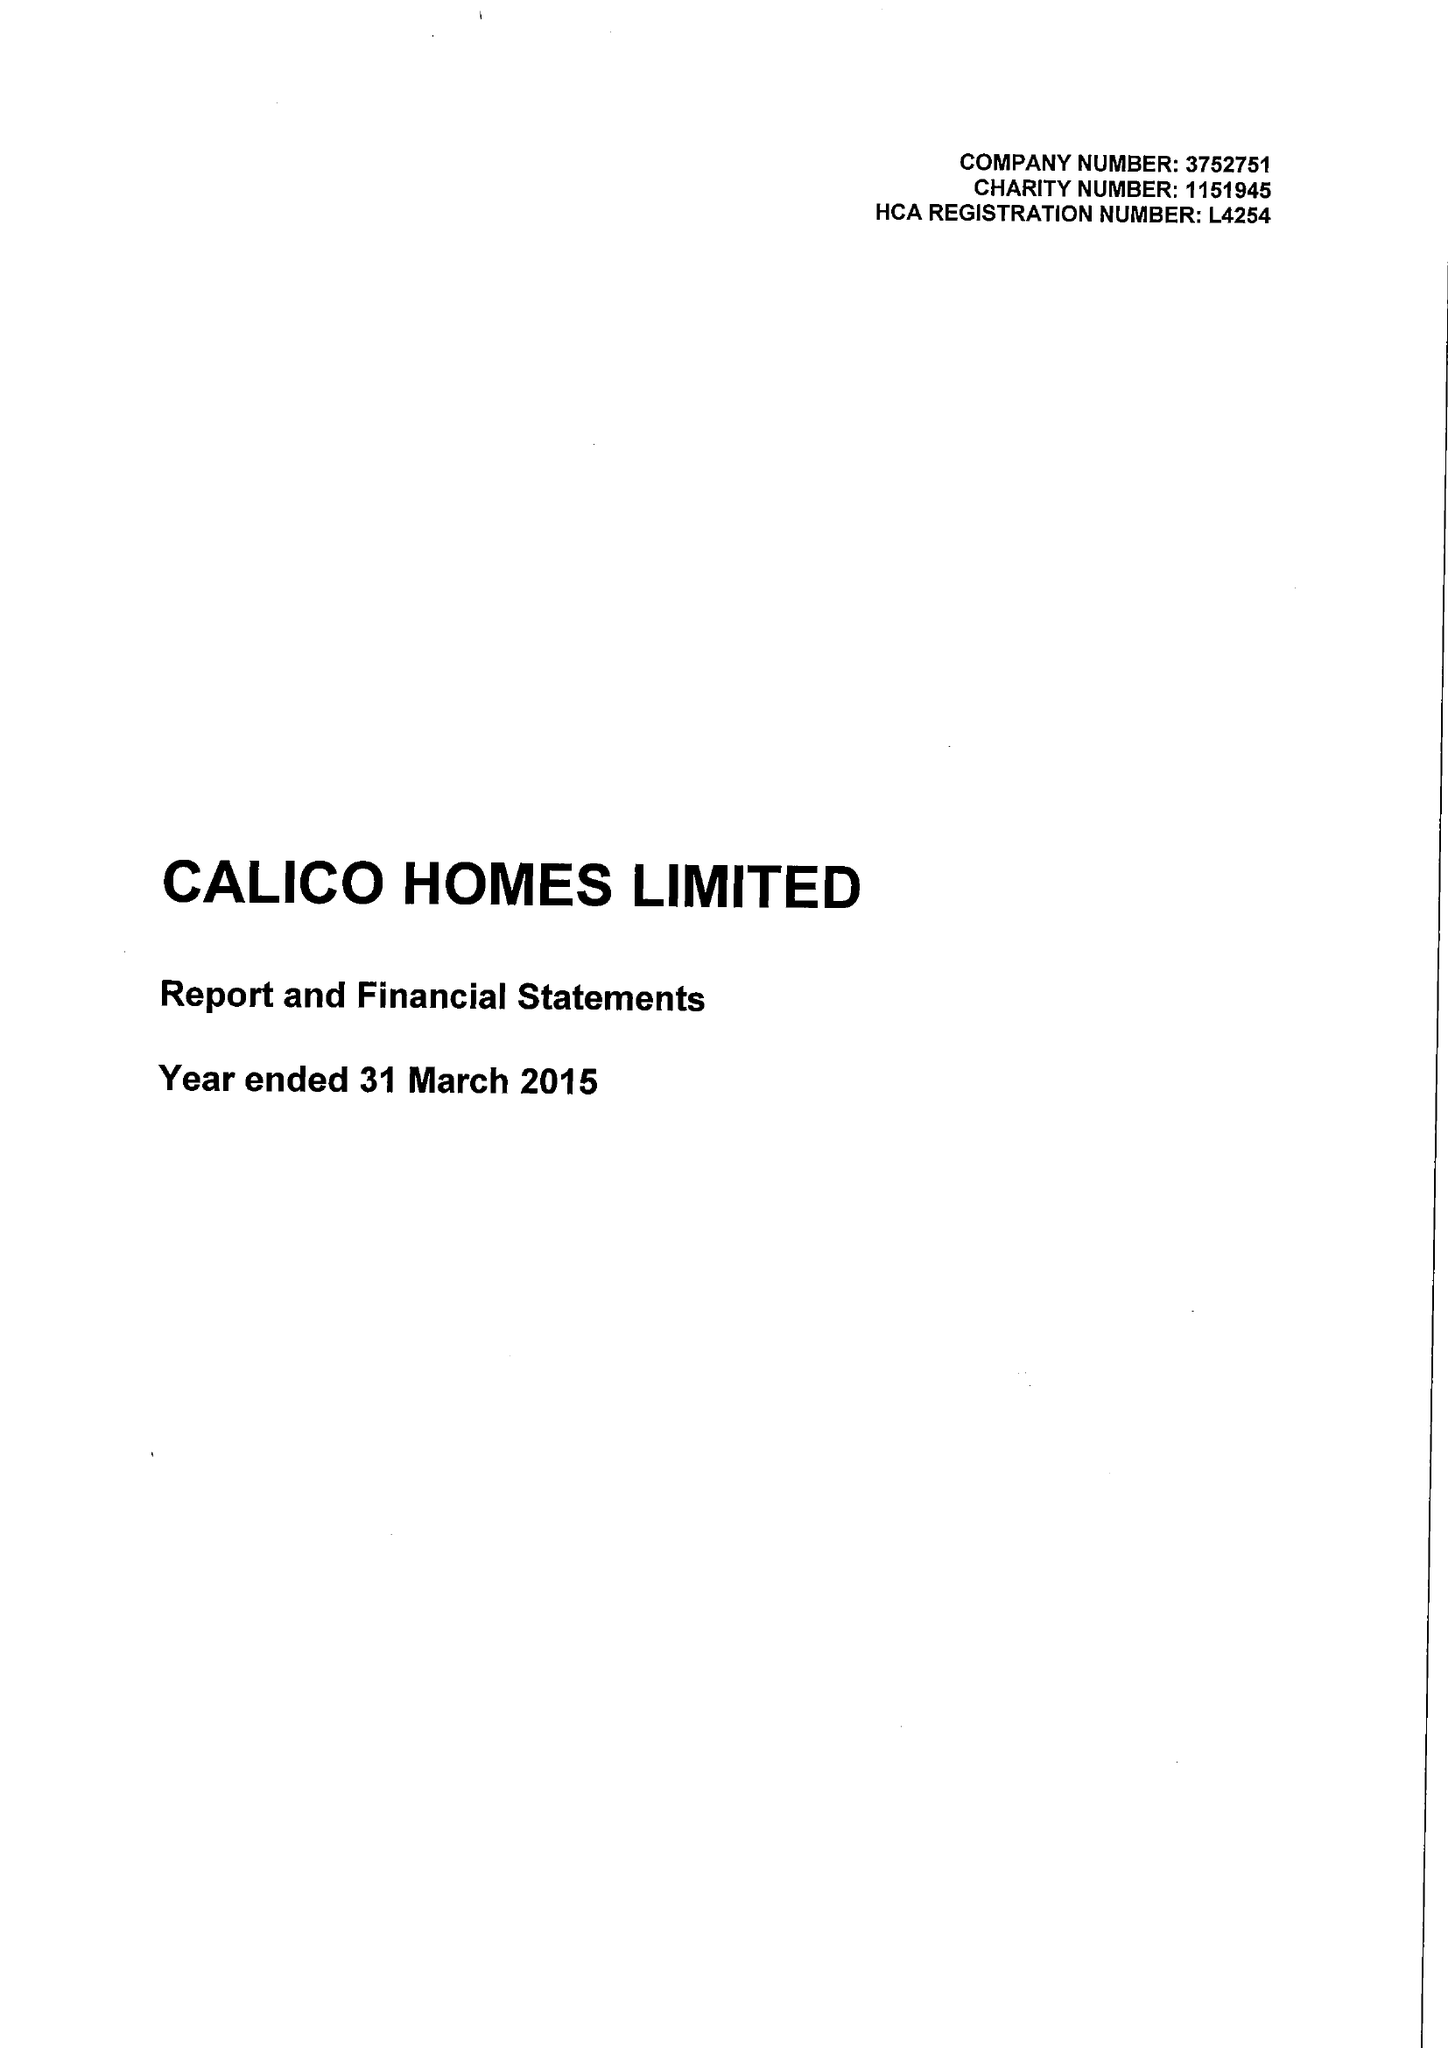What is the value for the spending_annually_in_british_pounds?
Answer the question using a single word or phrase. 20091000.00 